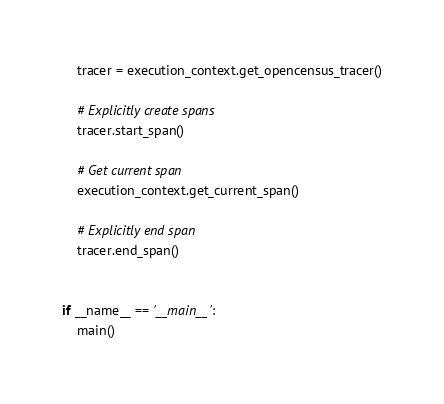<code> <loc_0><loc_0><loc_500><loc_500><_Python_>    tracer = execution_context.get_opencensus_tracer()

    # Explicitly create spans
    tracer.start_span()

    # Get current span
    execution_context.get_current_span()

    # Explicitly end span
    tracer.end_span()


if __name__ == '__main__':
    main()
</code> 